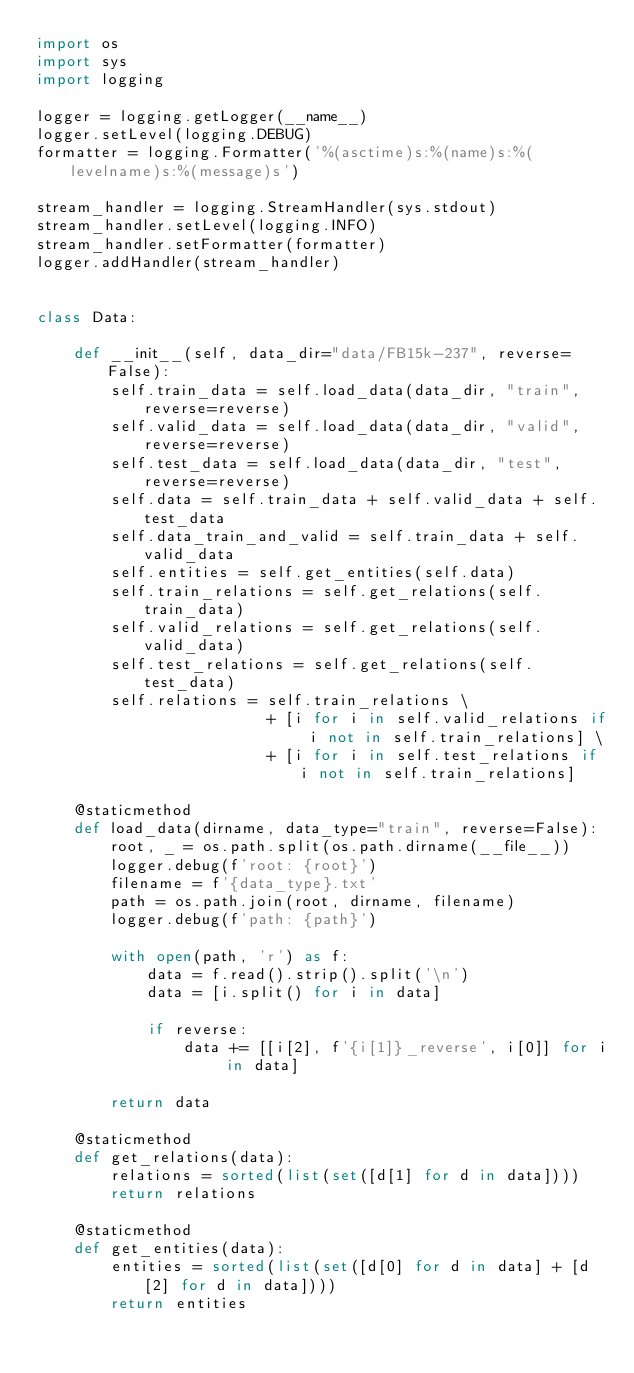Convert code to text. <code><loc_0><loc_0><loc_500><loc_500><_Python_>import os
import sys
import logging

logger = logging.getLogger(__name__)
logger.setLevel(logging.DEBUG)
formatter = logging.Formatter('%(asctime)s:%(name)s:%(levelname)s:%(message)s')

stream_handler = logging.StreamHandler(sys.stdout)
stream_handler.setLevel(logging.INFO)
stream_handler.setFormatter(formatter)
logger.addHandler(stream_handler)


class Data:

    def __init__(self, data_dir="data/FB15k-237", reverse=False):
        self.train_data = self.load_data(data_dir, "train", reverse=reverse)
        self.valid_data = self.load_data(data_dir, "valid", reverse=reverse)
        self.test_data = self.load_data(data_dir, "test", reverse=reverse)
        self.data = self.train_data + self.valid_data + self.test_data
        self.data_train_and_valid = self.train_data + self.valid_data
        self.entities = self.get_entities(self.data)
        self.train_relations = self.get_relations(self.train_data)
        self.valid_relations = self.get_relations(self.valid_data)
        self.test_relations = self.get_relations(self.test_data)
        self.relations = self.train_relations \
                         + [i for i in self.valid_relations if i not in self.train_relations] \
                         + [i for i in self.test_relations if i not in self.train_relations]

    @staticmethod
    def load_data(dirname, data_type="train", reverse=False):
        root, _ = os.path.split(os.path.dirname(__file__))
        logger.debug(f'root: {root}')
        filename = f'{data_type}.txt'
        path = os.path.join(root, dirname, filename)
        logger.debug(f'path: {path}')

        with open(path, 'r') as f:
            data = f.read().strip().split('\n')
            data = [i.split() for i in data]

            if reverse:
                data += [[i[2], f'{i[1]}_reverse', i[0]] for i in data]

        return data

    @staticmethod
    def get_relations(data):
        relations = sorted(list(set([d[1] for d in data])))
        return relations

    @staticmethod
    def get_entities(data):
        entities = sorted(list(set([d[0] for d in data] + [d[2] for d in data])))
        return entities
</code> 